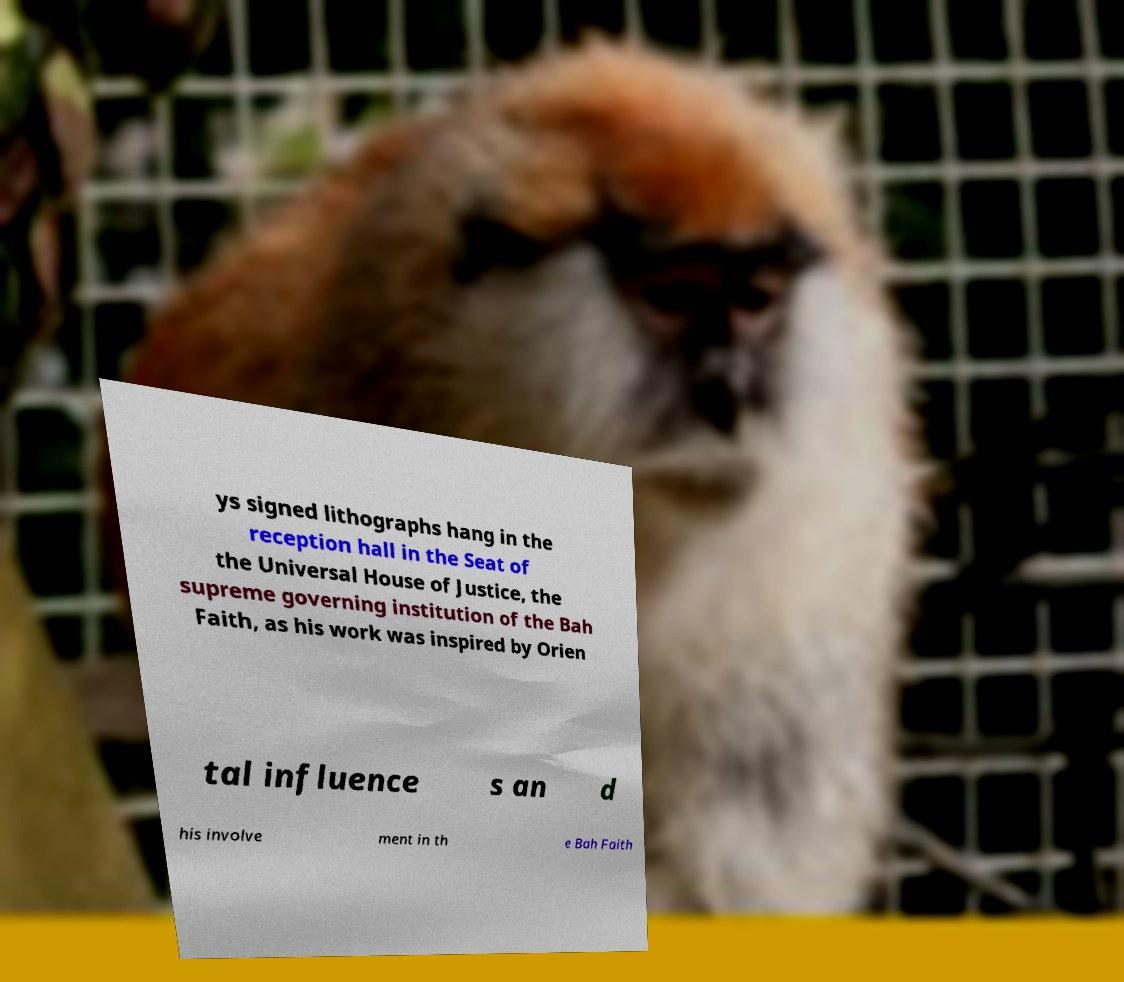There's text embedded in this image that I need extracted. Can you transcribe it verbatim? ys signed lithographs hang in the reception hall in the Seat of the Universal House of Justice, the supreme governing institution of the Bah Faith, as his work was inspired by Orien tal influence s an d his involve ment in th e Bah Faith 